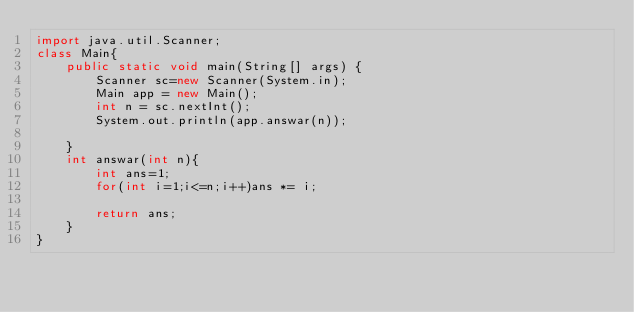Convert code to text. <code><loc_0><loc_0><loc_500><loc_500><_Java_>import java.util.Scanner;
class Main{
	public static void main(String[] args) {
		Scanner sc=new Scanner(System.in);
		Main app = new Main();
		int n = sc.nextInt();
		System.out.println(app.answar(n));
		
	}
	int answar(int n){
		int ans=1;
		for(int i=1;i<=n;i++)ans *= i;
		
		return ans;
	}
}</code> 